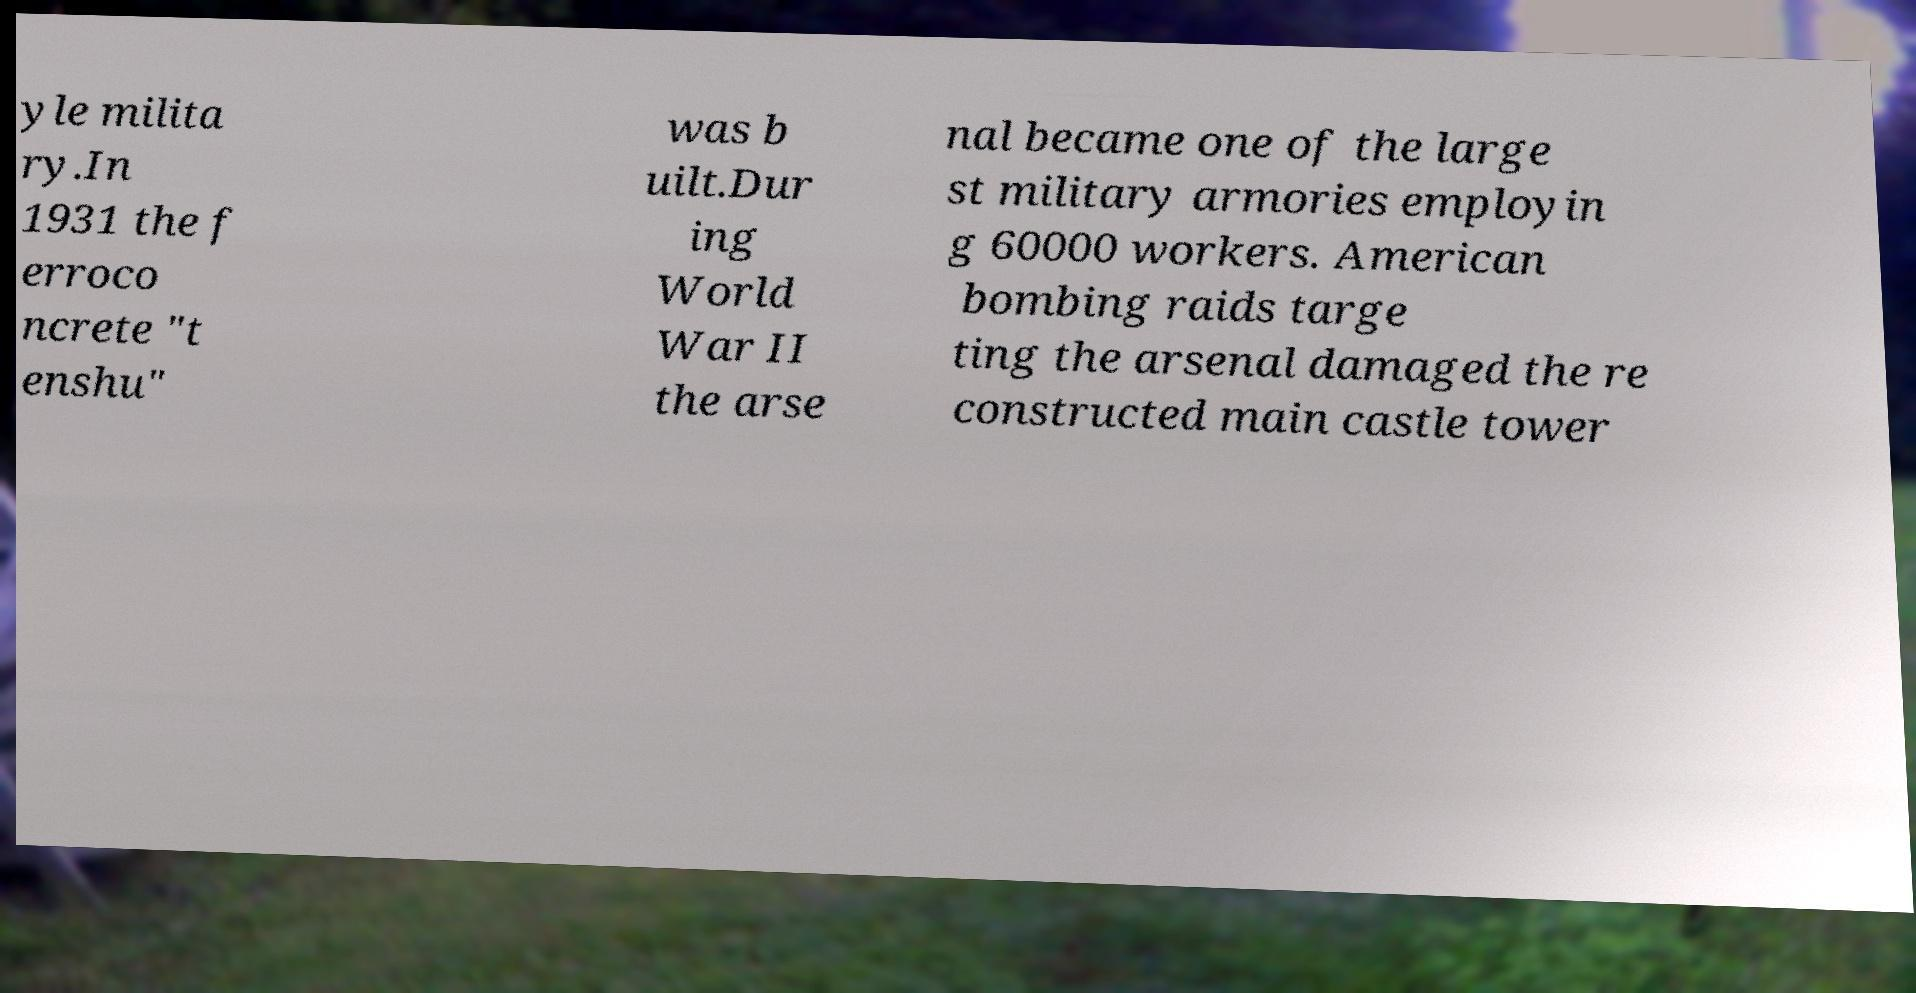Could you assist in decoding the text presented in this image and type it out clearly? yle milita ry.In 1931 the f erroco ncrete "t enshu" was b uilt.Dur ing World War II the arse nal became one of the large st military armories employin g 60000 workers. American bombing raids targe ting the arsenal damaged the re constructed main castle tower 